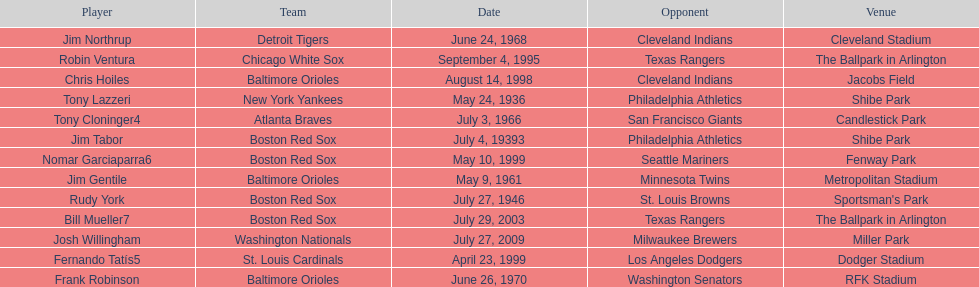What was the name of the last person to accomplish this up to date? Josh Willingham. 